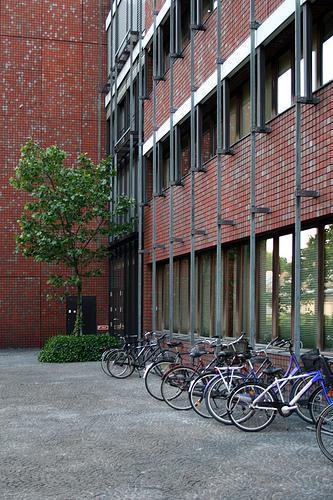How many bicycles?
Give a very brief answer. 8. 